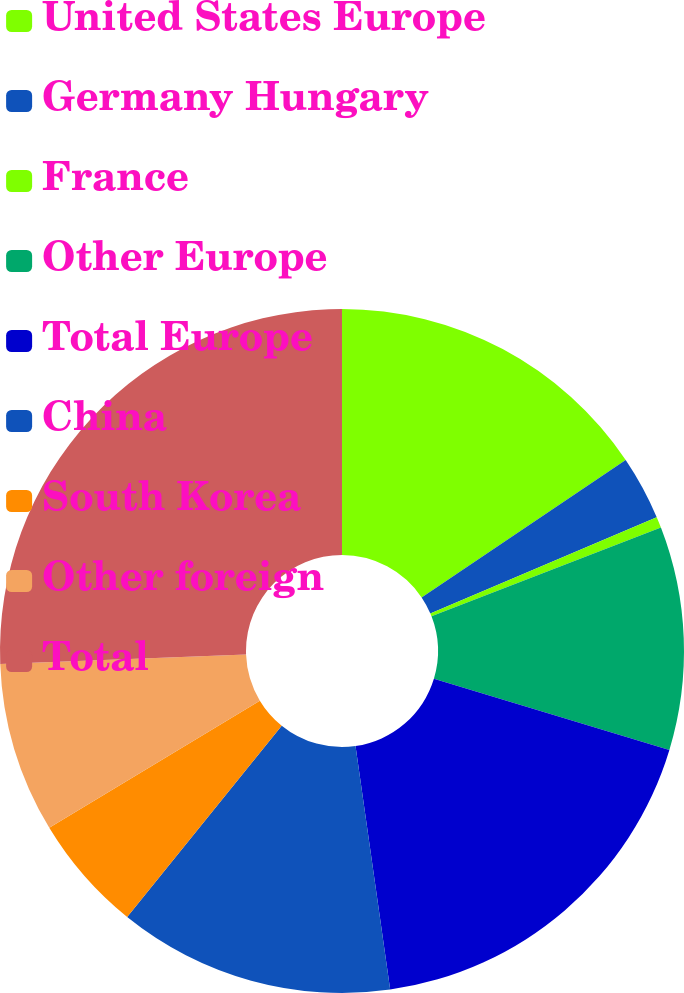Convert chart. <chart><loc_0><loc_0><loc_500><loc_500><pie_chart><fcel>United States Europe<fcel>Germany Hungary<fcel>France<fcel>Other Europe<fcel>Total Europe<fcel>China<fcel>South Korea<fcel>Other foreign<fcel>Total<nl><fcel>15.57%<fcel>3.03%<fcel>0.52%<fcel>10.55%<fcel>18.08%<fcel>13.06%<fcel>5.54%<fcel>8.05%<fcel>25.6%<nl></chart> 